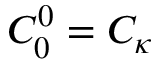<formula> <loc_0><loc_0><loc_500><loc_500>C _ { 0 } ^ { 0 } = C _ { \kappa }</formula> 